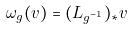Convert formula to latex. <formula><loc_0><loc_0><loc_500><loc_500>\omega _ { g } ( v ) = ( L _ { g ^ { - 1 } } ) _ { * } v</formula> 